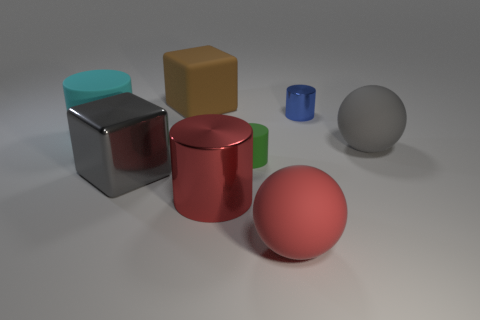Is there anything else that is the same material as the brown thing?
Give a very brief answer. Yes. Are there any big things that have the same color as the big shiny cylinder?
Make the answer very short. Yes. What number of big brown blocks have the same material as the gray block?
Your answer should be compact. 0. Is the shape of the metallic object to the left of the large brown object the same as  the tiny blue metallic thing?
Your answer should be compact. No. There is a large thing that is behind the big cyan cylinder; what is its shape?
Offer a very short reply. Cube. What is the material of the large brown thing?
Give a very brief answer. Rubber. There is a metal cylinder that is the same size as the brown matte thing; what is its color?
Give a very brief answer. Red. Does the big red metallic object have the same shape as the brown thing?
Provide a short and direct response. No. What is the material of the object that is behind the cyan matte cylinder and right of the big red matte object?
Keep it short and to the point. Metal. The gray block is what size?
Provide a short and direct response. Large. 